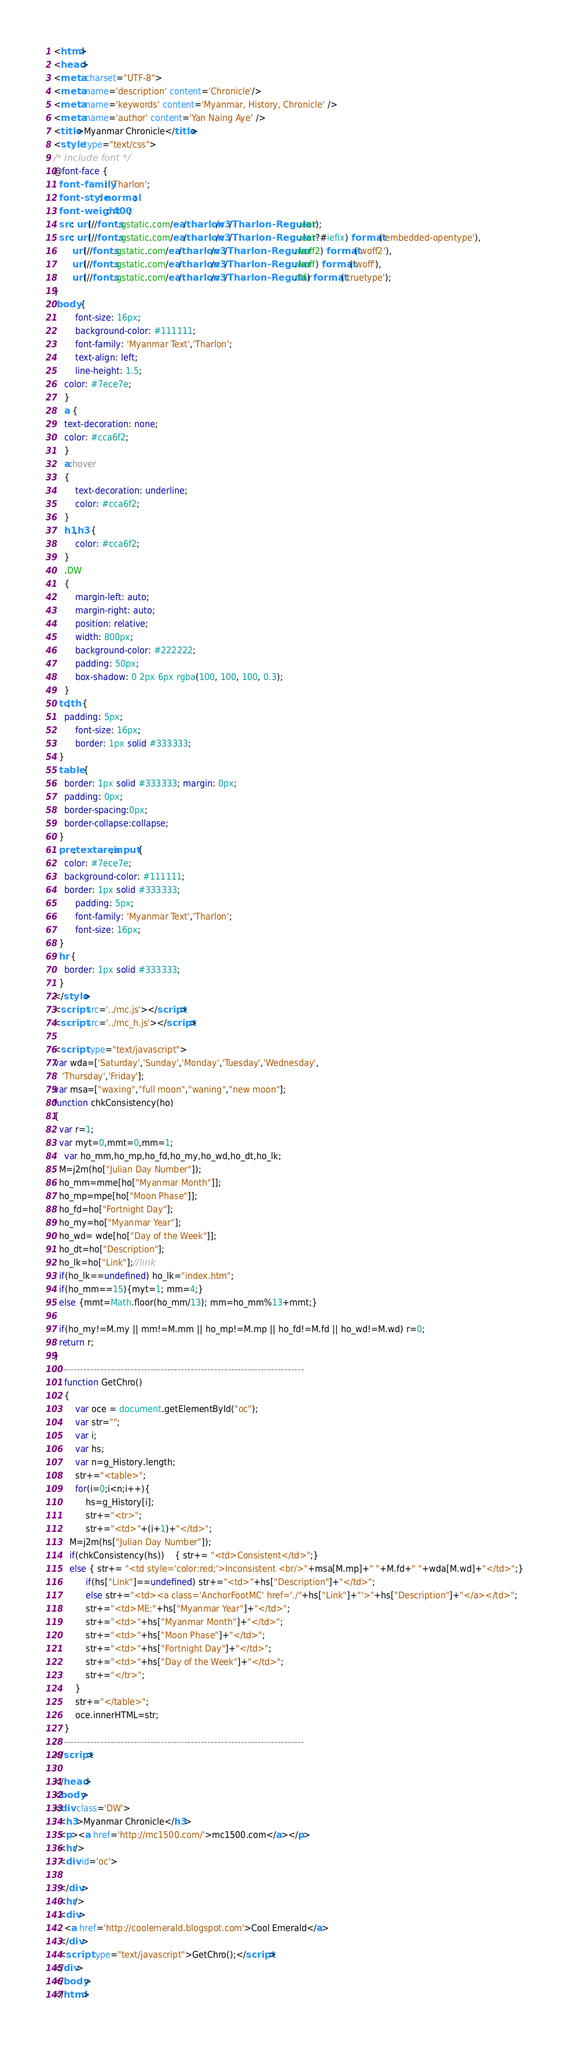<code> <loc_0><loc_0><loc_500><loc_500><_HTML_><html>
<head>
<meta charset="UTF-8">
<meta name='description' content='Chronicle'/>
<meta name='keywords' content='Myanmar, History, Chronicle' />
<meta name='author' content='Yan Naing Aye' />
<title>Myanmar Chronicle</title>
<style type="text/css">
/* include font */
@font-face {
  font-family: 'Tharlon';
  font-style: normal;
  font-weight: 400;
  src: url(//fonts.gstatic.com/ea/tharlon/v3/Tharlon-Regular.eot);
  src: url(//fonts.gstatic.com/ea/tharlon/v3/Tharlon-Regular.eot?#iefix) format('embedded-opentype'),
       url(//fonts.gstatic.com/ea/tharlon/v3/Tharlon-Regular.woff2) format('woff2'),
       url(//fonts.gstatic.com/ea/tharlon/v3/Tharlon-Regular.woff) format('woff'),
       url(//fonts.gstatic.com/ea/tharlon/v3/Tharlon-Regular.ttf) format('truetype');
}
 body {
		font-size: 16px;
		background-color: #111111;
		font-family: 'Myanmar Text','Tharlon';
		text-align: left;
		line-height: 1.5;
    color: #7ece7e;
	}
	a {
    text-decoration: none;
    color: #cca6f2;
	}
	a:hover
	{
		text-decoration: underline;
		color: #cca6f2;
	}
	h1,h3 {
		color: #cca6f2;
	}
	.DW
	{
		margin-left: auto;
		margin-right: auto;
		position: relative;
		width: 800px;
		background-color: #222222;
		padding: 50px;
		box-shadow: 0 2px 6px rgba(100, 100, 100, 0.3);
	}
  td,th {
    padding: 5px;
		font-size: 16px;
   		border: 1px solid #333333;
  }
  table {
    border: 1px solid #333333; margin: 0px;
    padding: 0px;
  	border-spacing:0px;
    border-collapse:collapse;
  }
  pre,textarea,input {
    color: #7ece7e;
    background-color: #111111;
    border: 1px solid #333333;
		padding: 5px;
		font-family: 'Myanmar Text','Tharlon';
		font-size: 16px;
  }
  hr {
    border: 1px solid #333333;
  }
</style>
<script src='../mc.js'></script>
<script src='../mc_h.js'></script>

<script type="text/javascript">
var wda=['Saturday','Sunday','Monday','Tuesday','Wednesday',
   'Thursday','Friday'];
var msa=["waxing","full moon","waning","new moon"];
function chkConsistency(ho)
{
  var r=1;
  var myt=0,mmt=0,mm=1;
	var ho_mm,ho_mp,ho_fd,ho_my,ho_wd,ho_dt,ho_lk;
  M=j2m(ho["Julian Day Number"]);
  ho_mm=mme[ho["Myanmar Month"]];
  ho_mp=mpe[ho["Moon Phase"]];
  ho_fd=ho["Fortnight Day"];
  ho_my=ho["Myanmar Year"];
  ho_wd= wde[ho["Day of the Week"]];
  ho_dt=ho["Description"];
  ho_lk=ho["Link"];//link
  if(ho_lk==undefined) ho_lk="index.htm";
  if(ho_mm==15){myt=1; mm=4;}
  else {mmt=Math.floor(ho_mm/13); mm=ho_mm%13+mmt;}

  if(ho_my!=M.my || mm!=M.mm || ho_mp!=M.mp || ho_fd!=M.fd || ho_wd!=M.wd) r=0;
  return r;
}
//-------------------------------------------------------------------------
	function GetChro()
	{
		var oce = document.getElementById("oc");
		var str="";
		var i;
		var hs;
		var n=g_History.length;
		str+="<table>";
		for(i=0;i<n;i++){
			hs=g_History[i];
			str+="<tr>";
			str+="<td>"+(i+1)+"</td>";
      M=j2m(hs["Julian Day Number"]);
      if(chkConsistency(hs))	{ str+= "<td>Consistent</td>";}
      else { str+= "<td style='color:red;'>Inconsistent <br/>"+msa[M.mp]+" "+M.fd+" "+wda[M.wd]+"</td>";}
			if(hs["Link"]==undefined) str+="<td>"+hs["Description"]+"</td>";
			else str+="<td><a class='AnchorFootMC' href='./"+hs["Link"]+"'>"+hs["Description"]+"</a></td>";
			str+="<td>ME:"+hs["Myanmar Year"]+"</td>";
			str+="<td>"+hs["Myanmar Month"]+"</td>";
			str+="<td>"+hs["Moon Phase"]+"</td>";
			str+="<td>"+hs["Fortnight Day"]+"</td>";
			str+="<td>"+hs["Day of the Week"]+"</td>";
			str+="</tr>";
		}
		str+="</table>";
		oce.innerHTML=str;
	}
//-------------------------------------------------------------------------
</script>

</head>
<body>
<div class='DW'>
  <h3>Myanmar Chronicle</h3>
  <p><a href='http://mc1500.com/'>mc1500.com</a></p>
  <hr/>
  <div id='oc'>

  </div>
  <hr/>
  <div>
  	<a href='http://coolemerald.blogspot.com'>Cool Emerald</a>
  </div>
  <script type="text/javascript">GetChro();</script>
</div>
</body>
</html>
</code> 